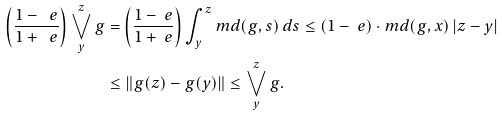Convert formula to latex. <formula><loc_0><loc_0><loc_500><loc_500>\left ( \frac { 1 - \ e } { 1 + \ e } \right ) \bigvee ^ { z } _ { y } g & = \left ( \frac { 1 - \ e } { 1 + \ e } \right ) \int ^ { z } _ { y } m d ( g , s ) \, d s \leq ( 1 - \ e ) \cdot m d ( g , x ) \, | z - y | \\ & \leq \| g ( z ) - g ( y ) \| \leq \bigvee ^ { z } _ { y } g .</formula> 